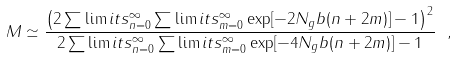<formula> <loc_0><loc_0><loc_500><loc_500>M \simeq \frac { \left ( 2 \sum \lim i t s _ { n = 0 } ^ { \infty } \sum \lim i t s _ { m = 0 } ^ { \infty } \exp [ - 2 N _ { g } b ( n + 2 m ) ] - 1 \right ) ^ { 2 } } { 2 \sum \lim i t s _ { n = 0 } ^ { \infty } \sum \lim i t s _ { m = 0 } ^ { \infty } \exp [ - 4 N _ { g } b ( n + 2 m ) ] - 1 } \ ,</formula> 